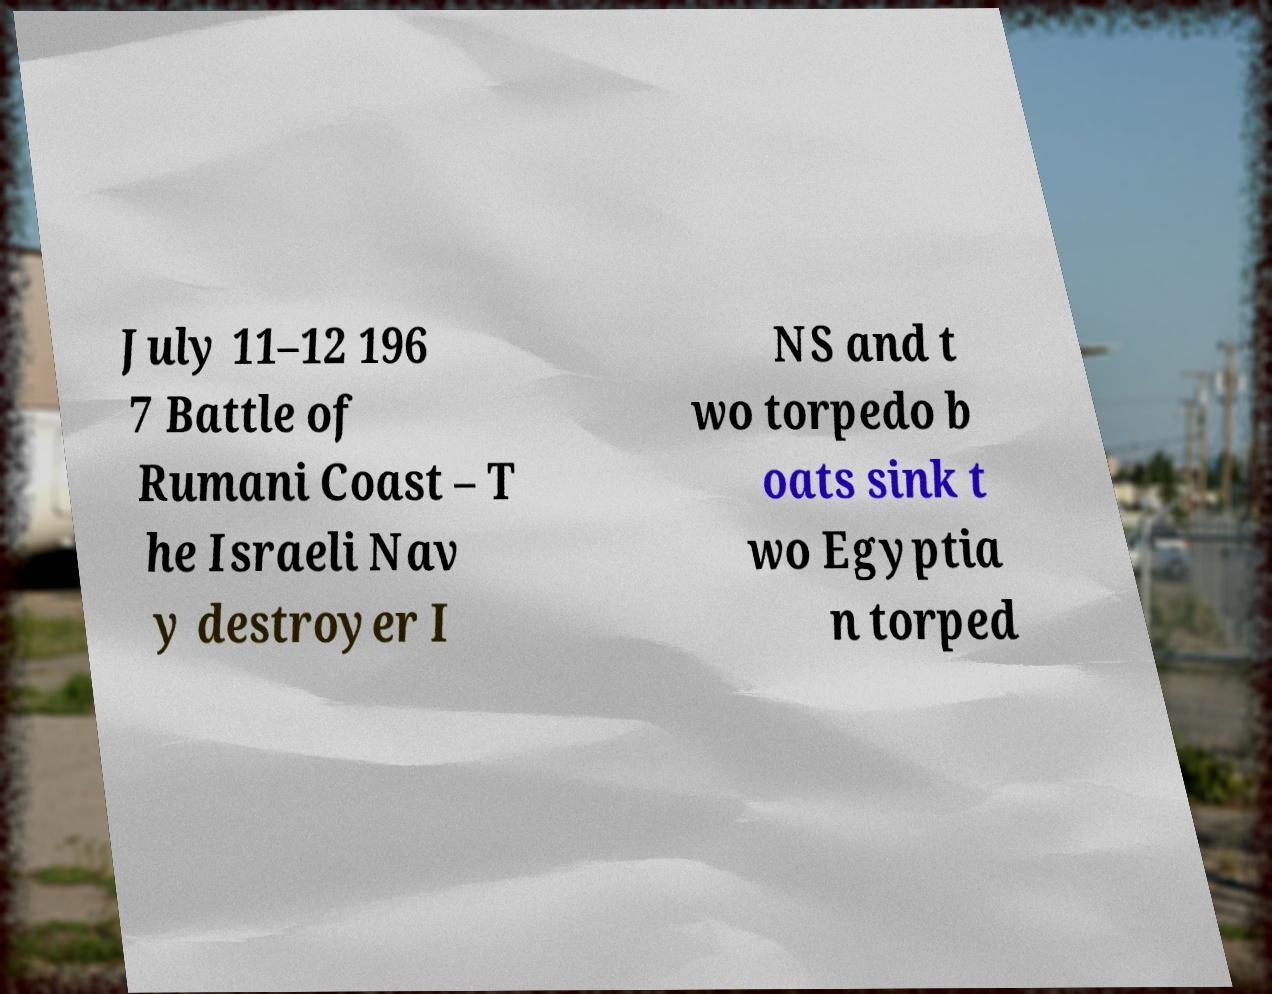For documentation purposes, I need the text within this image transcribed. Could you provide that? July 11–12 196 7 Battle of Rumani Coast – T he Israeli Nav y destroyer I NS and t wo torpedo b oats sink t wo Egyptia n torped 